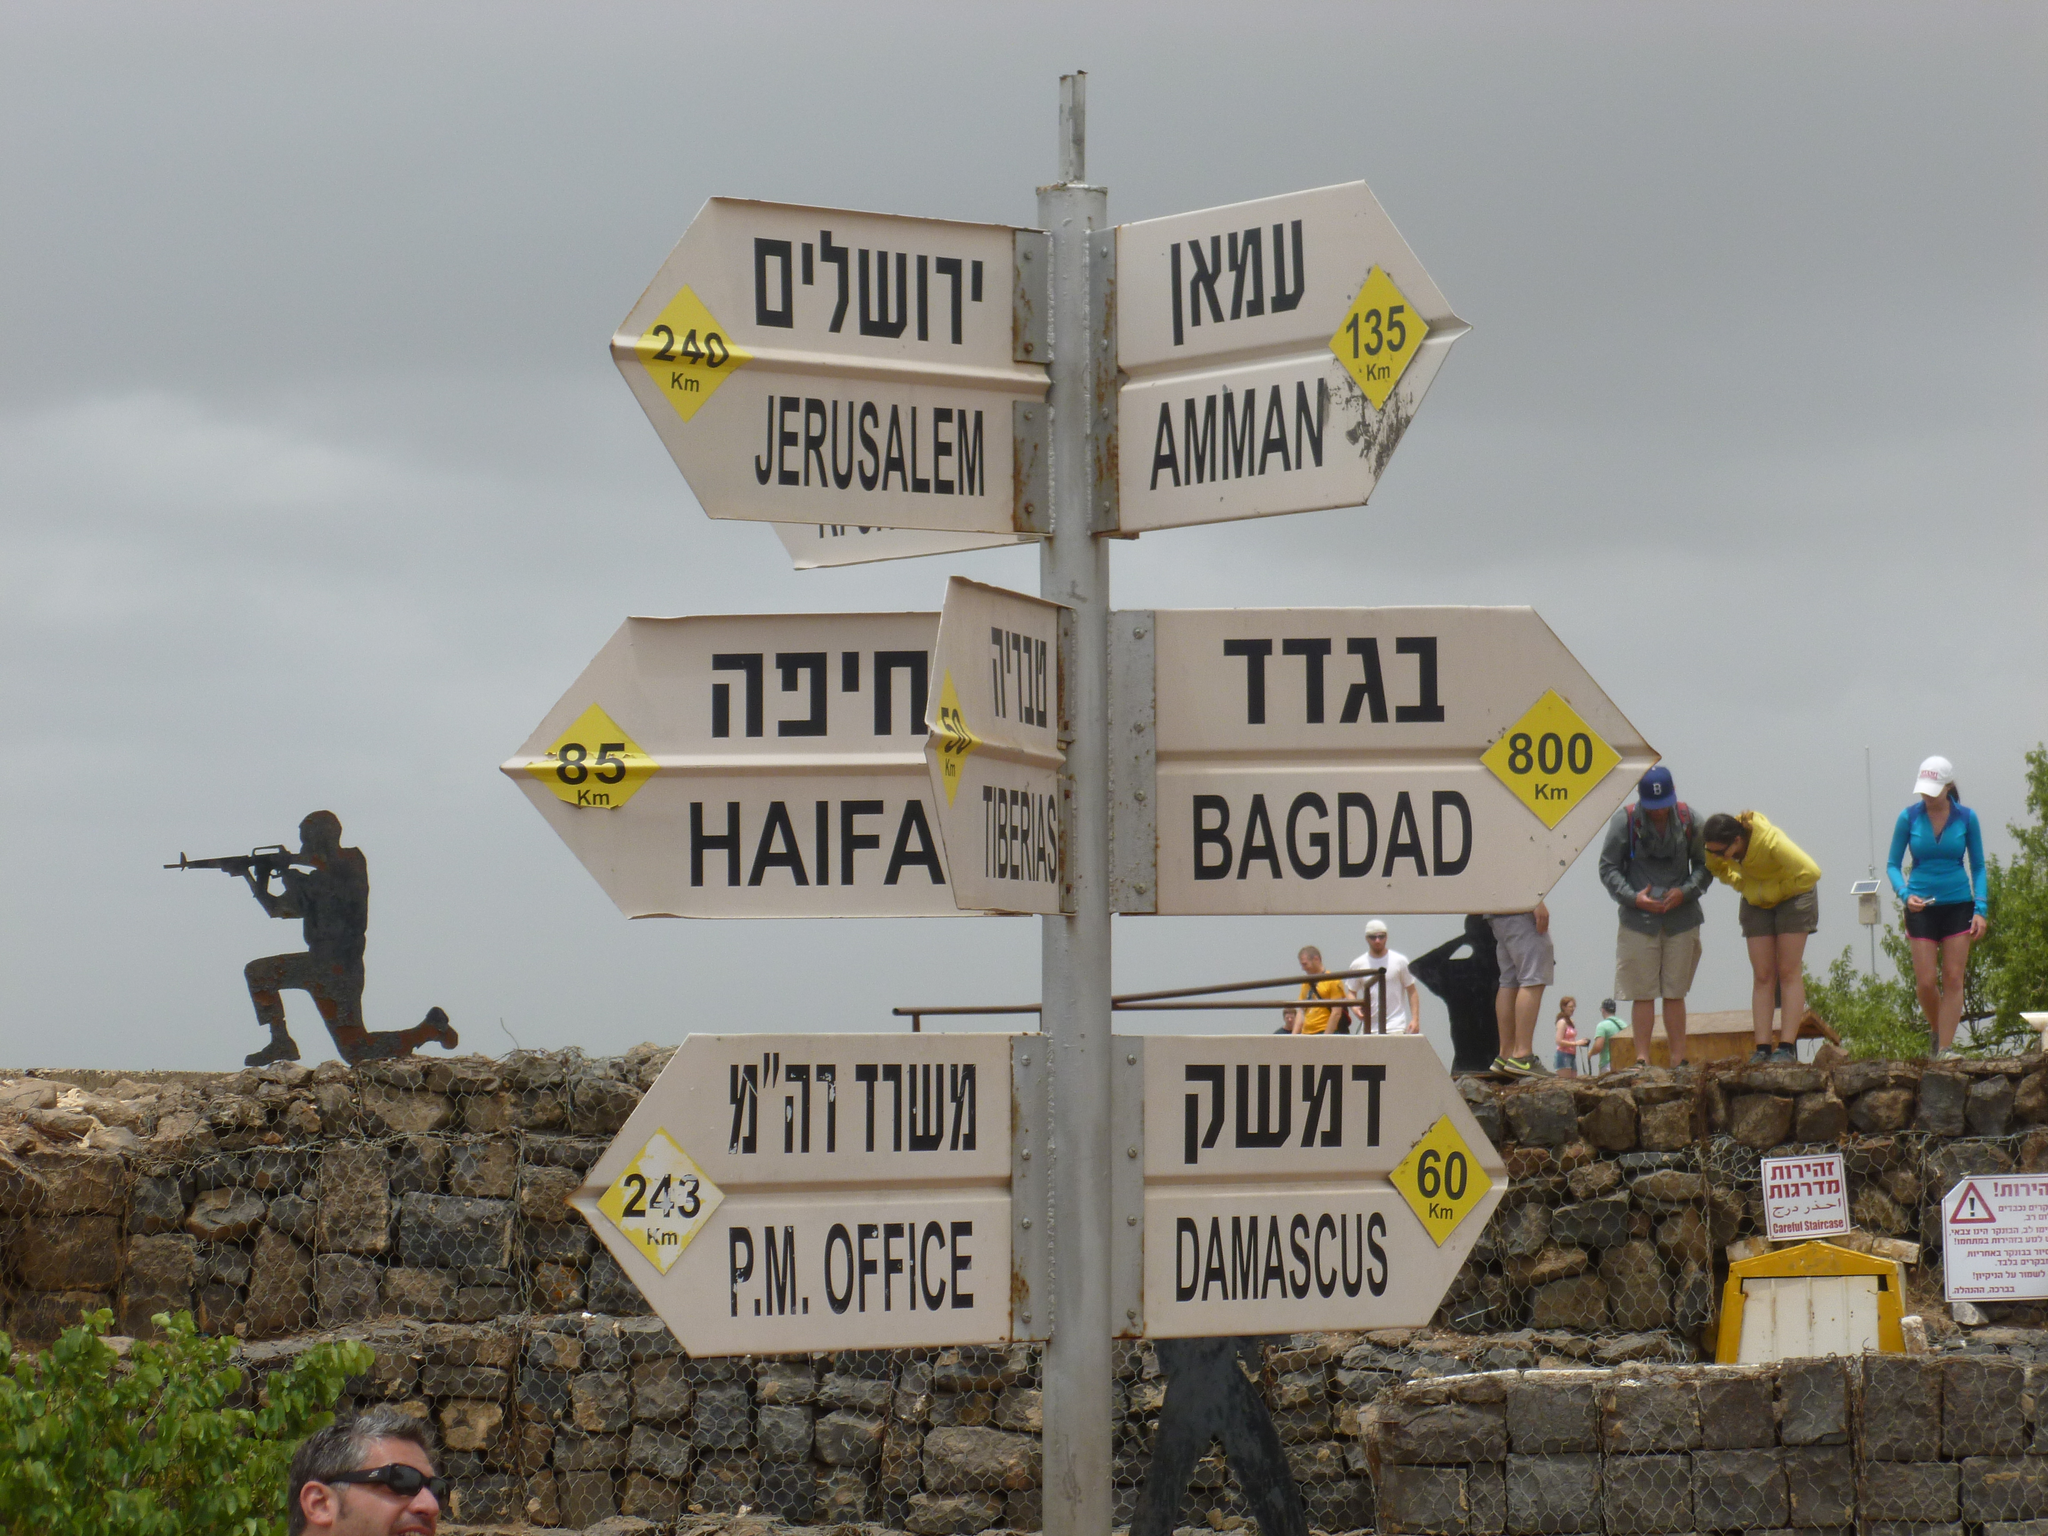Provide a one-sentence caption for the provided image. Multiple signs on top of one another with the bottom one saying "Damascus". 